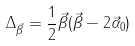<formula> <loc_0><loc_0><loc_500><loc_500>\Delta _ { \vec { \beta } } = \frac { 1 } { 2 } \vec { \beta } ( \vec { \beta } - 2 \vec { \alpha } _ { 0 } )</formula> 